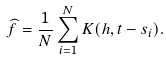<formula> <loc_0><loc_0><loc_500><loc_500>\widehat { f } = \frac { 1 } { N } \sum _ { i = 1 } ^ { N } K ( h , t - s _ { i } ) .</formula> 